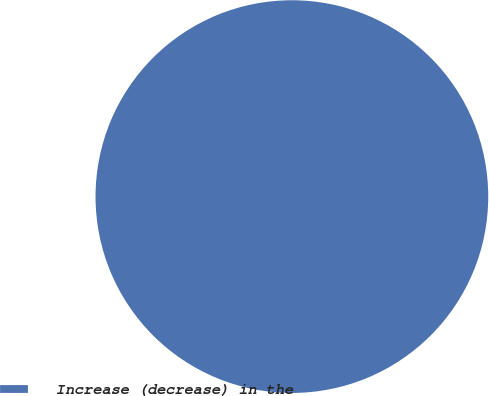<chart> <loc_0><loc_0><loc_500><loc_500><pie_chart><fcel>Increase (decrease) in the<nl><fcel>100.0%<nl></chart> 